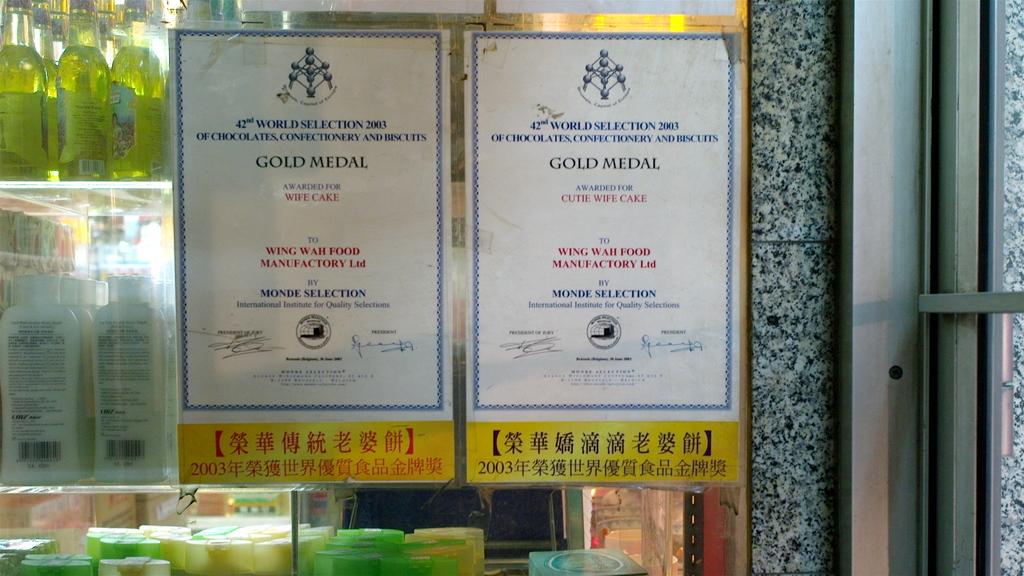What do the papers say?
Offer a very short reply. Gold medal. 